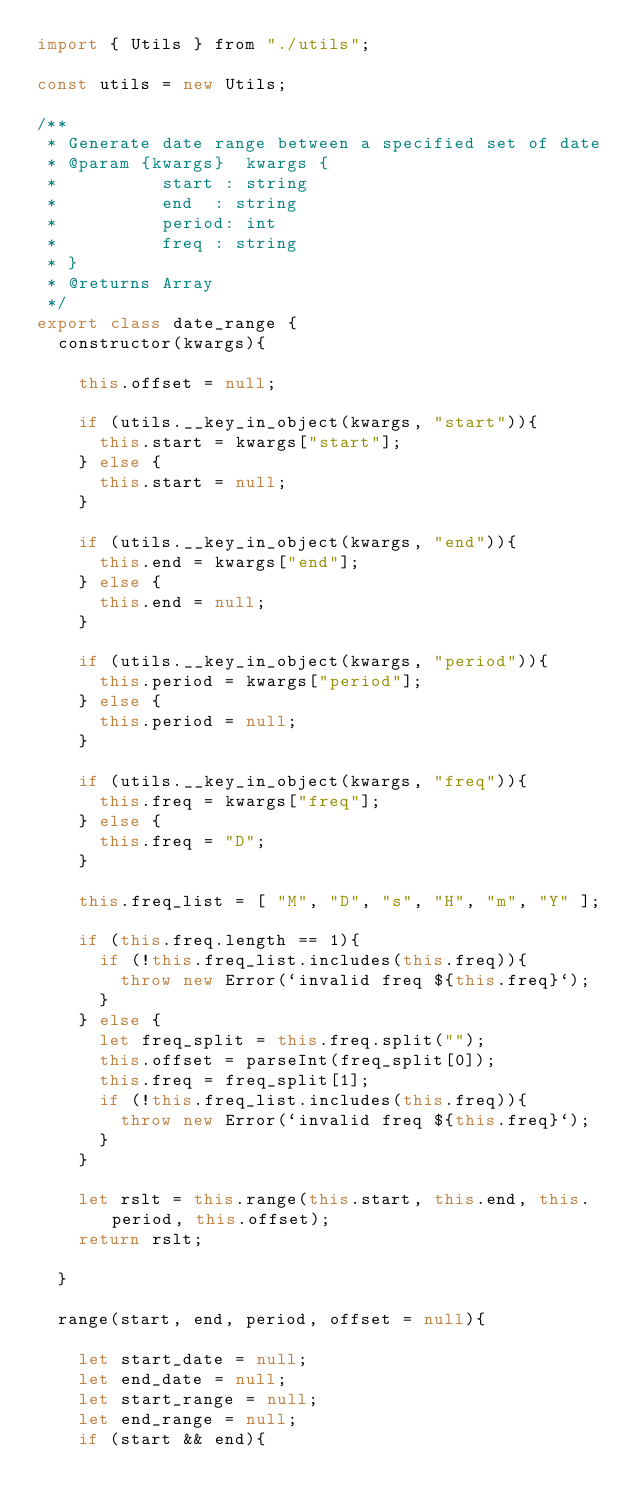Convert code to text. <code><loc_0><loc_0><loc_500><loc_500><_JavaScript_>import { Utils } from "./utils";

const utils = new Utils;

/**
 * Generate date range between a specified set of date
 * @param {kwargs}  kwargs {
 *          start : string
 *          end  : string
 *          period: int
 *          freq : string
 * }
 * @returns Array
 */
export class date_range {
  constructor(kwargs){

    this.offset = null;

    if (utils.__key_in_object(kwargs, "start")){
      this.start = kwargs["start"];
    } else {
      this.start = null;
    }

    if (utils.__key_in_object(kwargs, "end")){
      this.end = kwargs["end"];
    } else {
      this.end = null;
    }

    if (utils.__key_in_object(kwargs, "period")){
      this.period = kwargs["period"];
    } else {
      this.period = null;
    }

    if (utils.__key_in_object(kwargs, "freq")){
      this.freq = kwargs["freq"];
    } else {
      this.freq = "D";
    }

    this.freq_list = [ "M", "D", "s", "H", "m", "Y" ];

    if (this.freq.length == 1){
      if (!this.freq_list.includes(this.freq)){
        throw new Error(`invalid freq ${this.freq}`);
      }
    } else {
      let freq_split = this.freq.split("");
      this.offset = parseInt(freq_split[0]);
      this.freq = freq_split[1];
      if (!this.freq_list.includes(this.freq)){
        throw new Error(`invalid freq ${this.freq}`);
      }
    }

    let rslt = this.range(this.start, this.end, this.period, this.offset);
    return rslt;

  }

  range(start, end, period, offset = null){

    let start_date = null;
    let end_date = null;
    let start_range = null;
    let end_range = null;
    if (start && end){</code> 